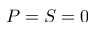Convert formula to latex. <formula><loc_0><loc_0><loc_500><loc_500>P = S = 0</formula> 